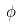<formula> <loc_0><loc_0><loc_500><loc_500>\phi</formula> 